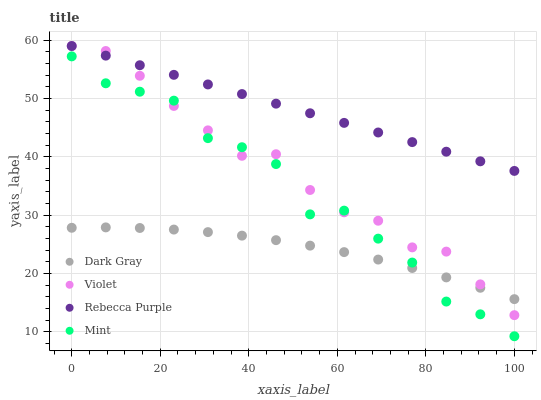Does Dark Gray have the minimum area under the curve?
Answer yes or no. Yes. Does Rebecca Purple have the maximum area under the curve?
Answer yes or no. Yes. Does Mint have the minimum area under the curve?
Answer yes or no. No. Does Mint have the maximum area under the curve?
Answer yes or no. No. Is Rebecca Purple the smoothest?
Answer yes or no. Yes. Is Mint the roughest?
Answer yes or no. Yes. Is Mint the smoothest?
Answer yes or no. No. Is Rebecca Purple the roughest?
Answer yes or no. No. Does Mint have the lowest value?
Answer yes or no. Yes. Does Rebecca Purple have the lowest value?
Answer yes or no. No. Does Violet have the highest value?
Answer yes or no. Yes. Does Mint have the highest value?
Answer yes or no. No. Is Dark Gray less than Rebecca Purple?
Answer yes or no. Yes. Is Rebecca Purple greater than Mint?
Answer yes or no. Yes. Does Mint intersect Violet?
Answer yes or no. Yes. Is Mint less than Violet?
Answer yes or no. No. Is Mint greater than Violet?
Answer yes or no. No. Does Dark Gray intersect Rebecca Purple?
Answer yes or no. No. 